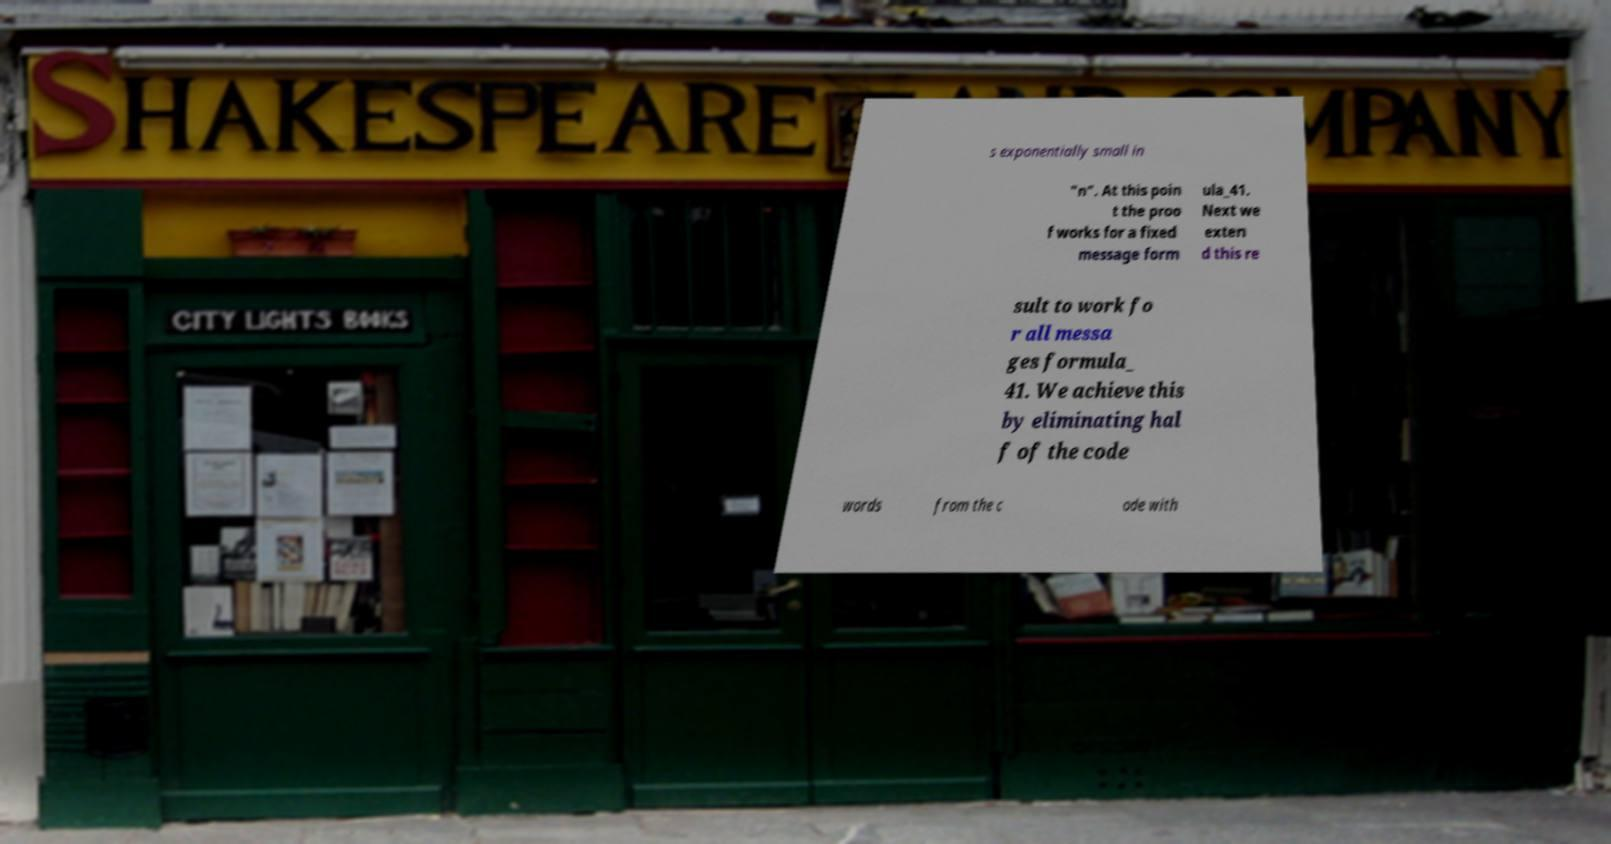Please read and relay the text visible in this image. What does it say? s exponentially small in "n". At this poin t the proo f works for a fixed message form ula_41. Next we exten d this re sult to work fo r all messa ges formula_ 41. We achieve this by eliminating hal f of the code words from the c ode with 